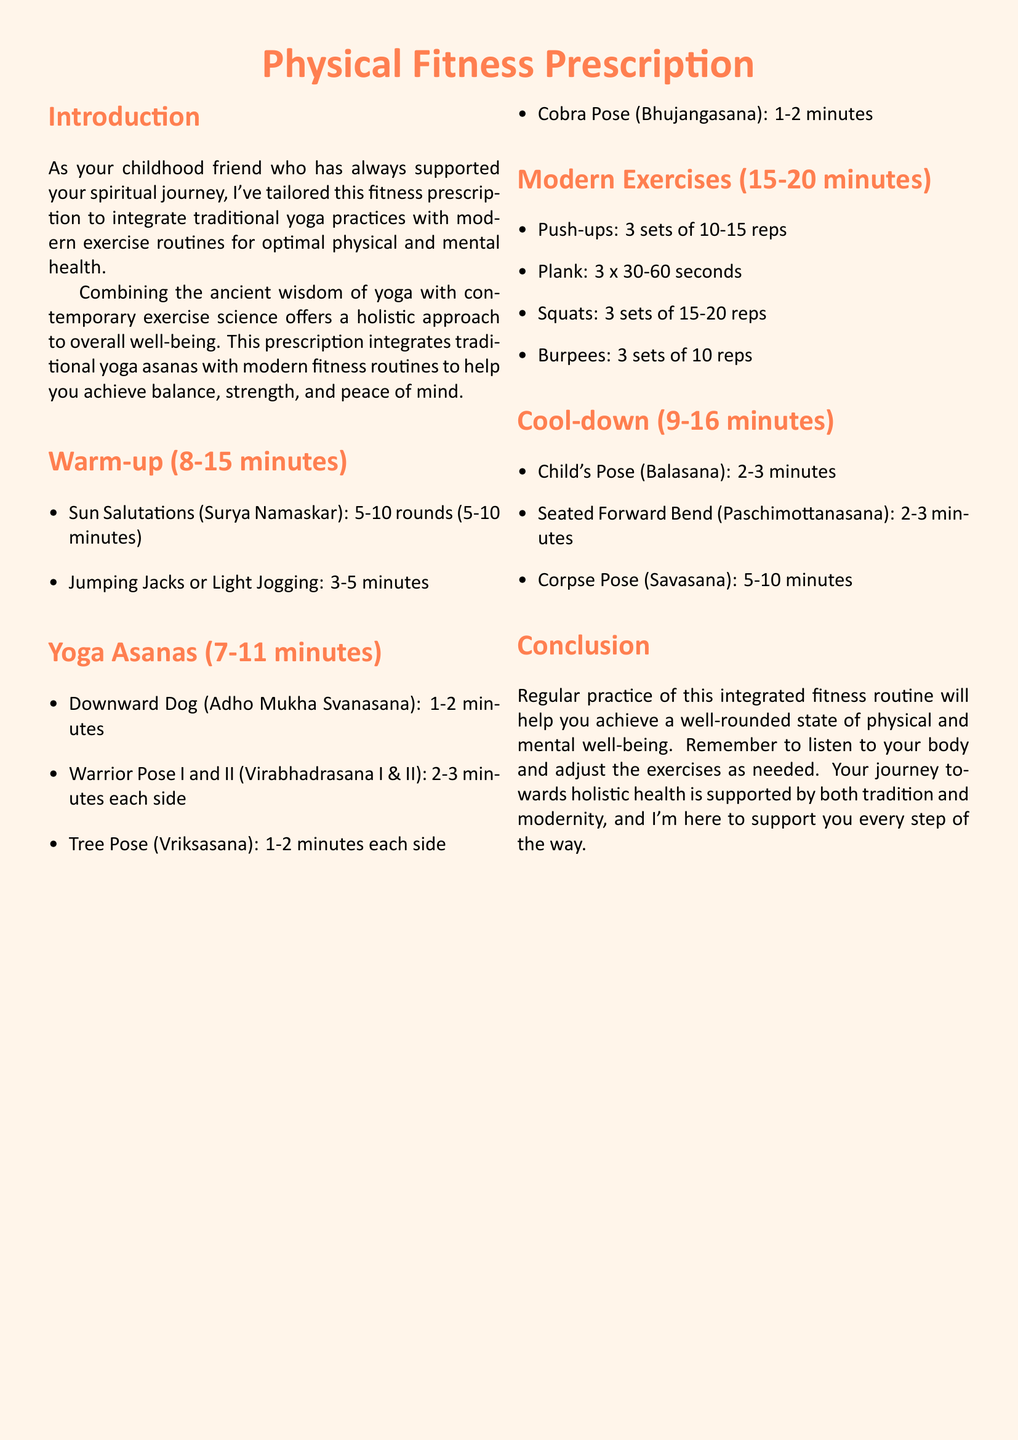What is the title of the document? The title of the document is prominently displayed in a large font and is "Physical Fitness Prescription."
Answer: Physical Fitness Prescription How long should the warm-up last? The warm-up section indicates it should last 8-15 minutes.
Answer: 8-15 minutes What pose is suggested for the cool-down? The document lists several positions for cool-down, including Child's Pose (Balasana).
Answer: Child's Pose How many rounds of Sun Salutations are recommended? The warm-up section specifies that 5-10 rounds of Sun Salutations are recommended.
Answer: 5-10 rounds What is the duration of the Downward Dog asana? The Yoga Asanas section states that Downward Dog should last 1-2 minutes.
Answer: 1-2 minutes What exercise involves 3 sets of 10-15 reps? The Modern Exercises section mentions that Push-ups are performed in 3 sets of 10-15 reps.
Answer: Push-ups What is the main goal of combining yoga and modern exercise? The introduction outlines that the goal is to achieve balance, strength, and peace of mind.
Answer: Balance, strength, and peace of mind Which pose in the cool-down lasts the longest? The cool-down suggests that Corpse Pose (Savasana) should last 5-10 minutes, which is the longest duration.
Answer: Corpse Pose (Savasana) 